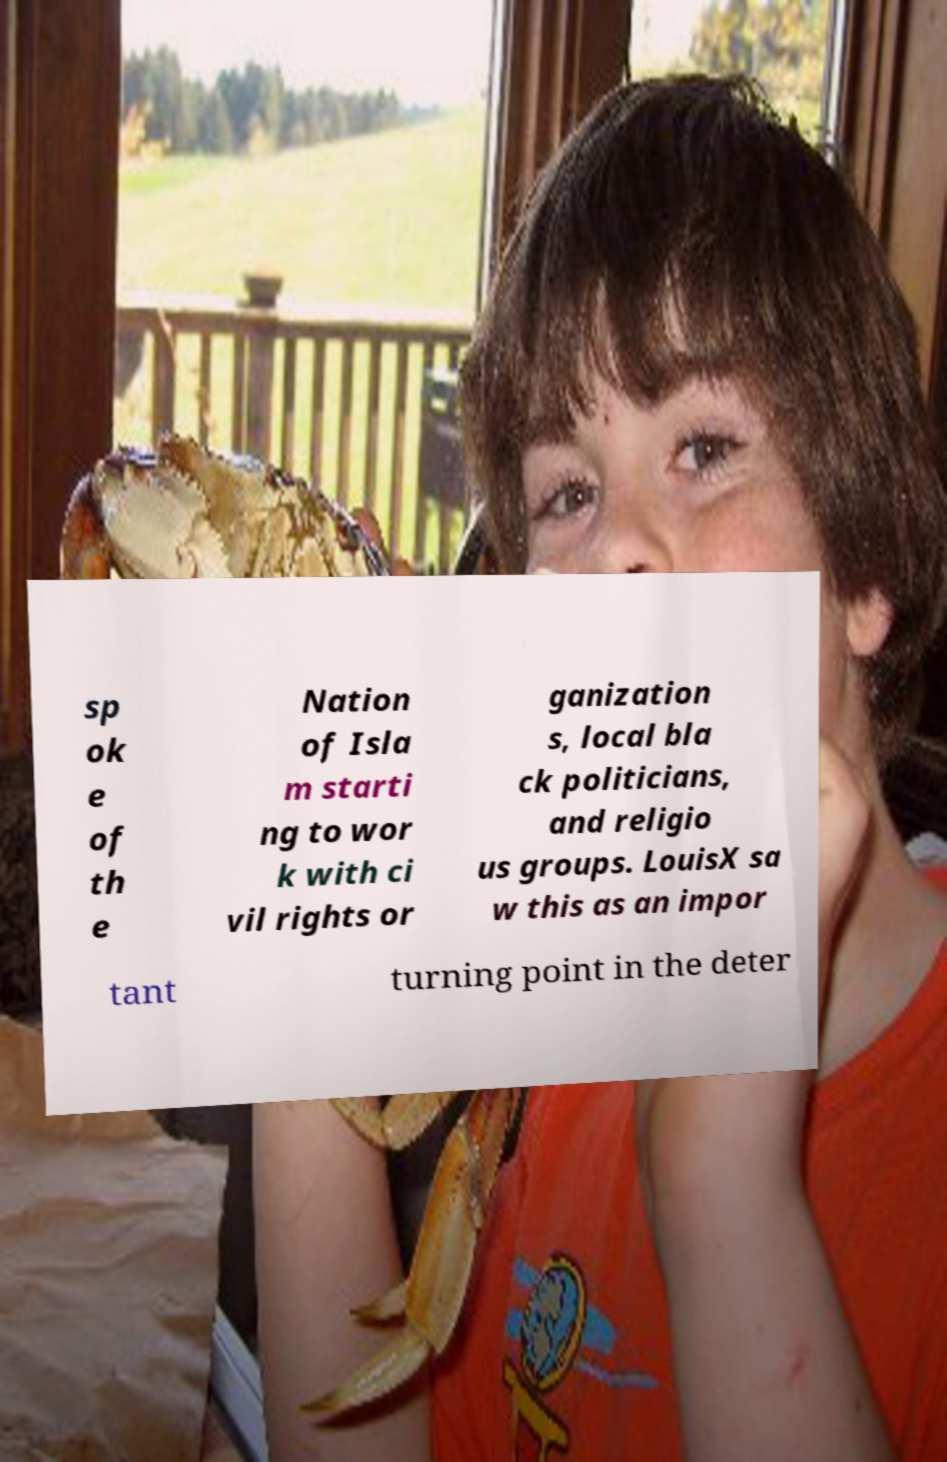What messages or text are displayed in this image? I need them in a readable, typed format. sp ok e of th e Nation of Isla m starti ng to wor k with ci vil rights or ganization s, local bla ck politicians, and religio us groups. LouisX sa w this as an impor tant turning point in the deter 